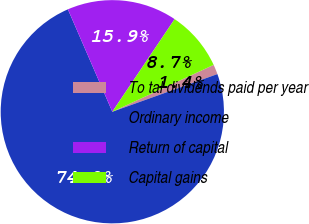Convert chart to OTSL. <chart><loc_0><loc_0><loc_500><loc_500><pie_chart><fcel>To tal dividends paid per year<fcel>Ordinary income<fcel>Return of capital<fcel>Capital gains<nl><fcel>1.42%<fcel>73.97%<fcel>15.94%<fcel>8.68%<nl></chart> 